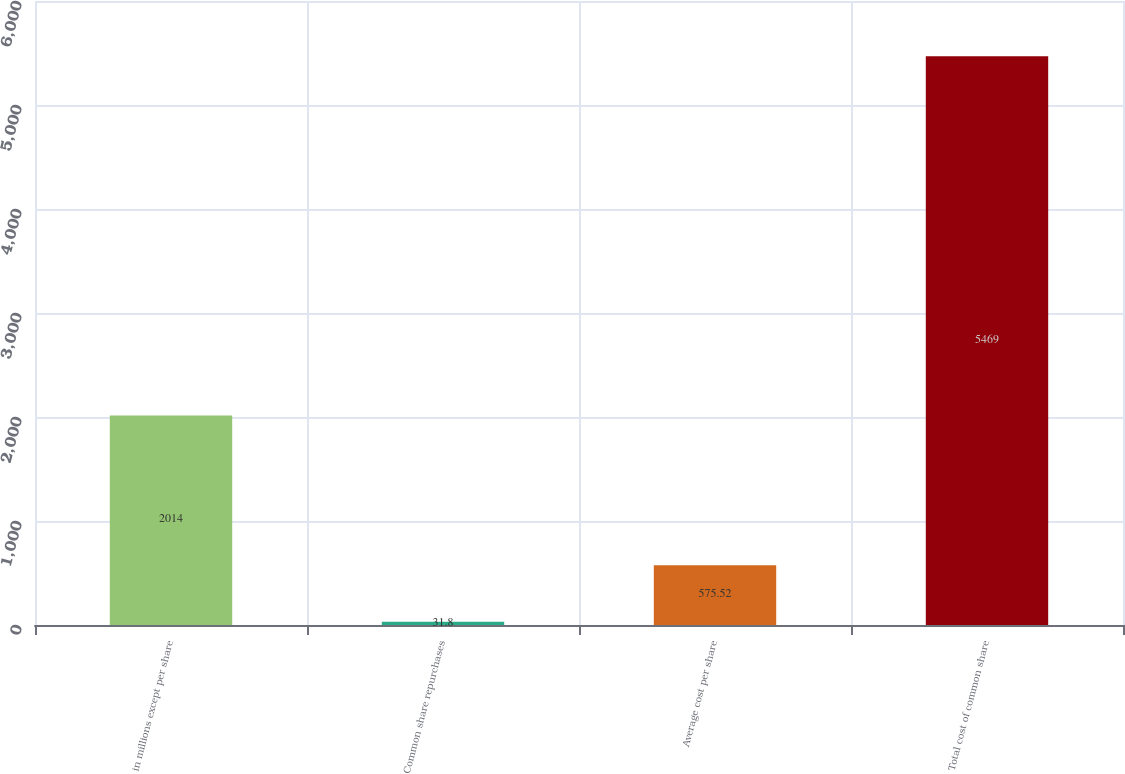Convert chart. <chart><loc_0><loc_0><loc_500><loc_500><bar_chart><fcel>in millions except per share<fcel>Common share repurchases<fcel>Average cost per share<fcel>Total cost of common share<nl><fcel>2014<fcel>31.8<fcel>575.52<fcel>5469<nl></chart> 